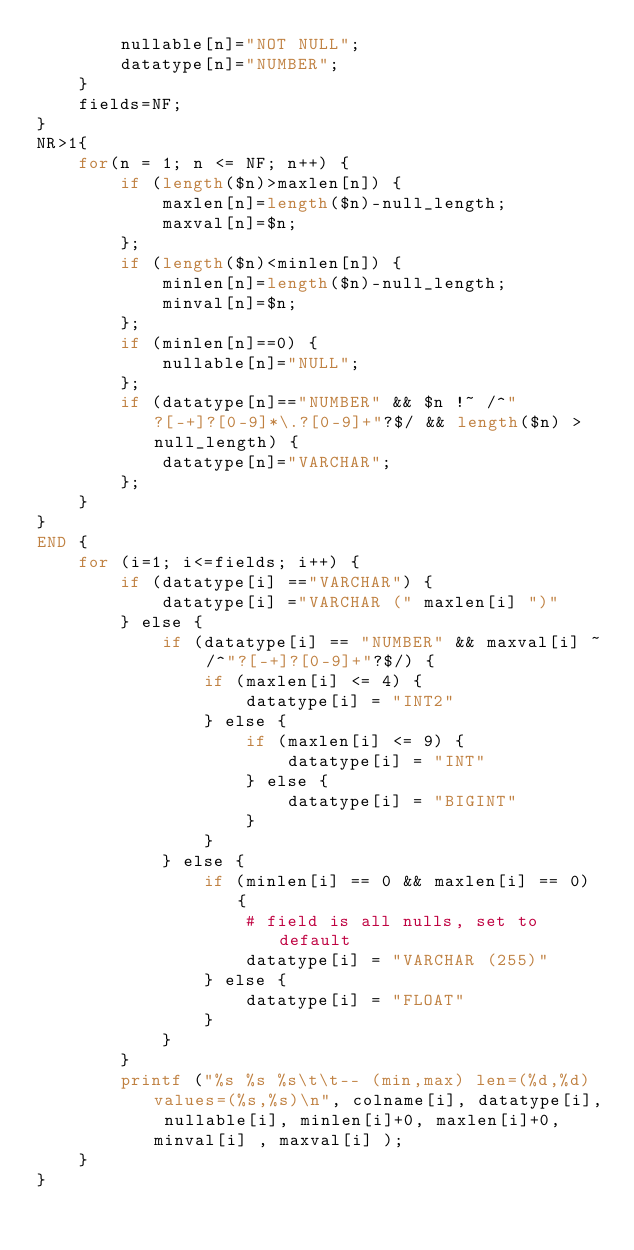<code> <loc_0><loc_0><loc_500><loc_500><_Awk_>        nullable[n]="NOT NULL";
        datatype[n]="NUMBER";
    }
    fields=NF;
}
NR>1{
    for(n = 1; n <= NF; n++) {
        if (length($n)>maxlen[n]) {
            maxlen[n]=length($n)-null_length;
            maxval[n]=$n;
        };
        if (length($n)<minlen[n]) {
            minlen[n]=length($n)-null_length;
            minval[n]=$n;
        };
        if (minlen[n]==0) {
            nullable[n]="NULL";
        };
        if (datatype[n]=="NUMBER" && $n !~ /^"?[-+]?[0-9]*\.?[0-9]+"?$/ && length($n) > null_length) {
            datatype[n]="VARCHAR";
        };
    }
}
END {
    for (i=1; i<=fields; i++) {
        if (datatype[i] =="VARCHAR") {
            datatype[i] ="VARCHAR (" maxlen[i] ")"
        } else {
            if (datatype[i] == "NUMBER" && maxval[i] ~ /^"?[-+]?[0-9]+"?$/) {
                if (maxlen[i] <= 4) {
                    datatype[i] = "INT2"
                } else {
                    if (maxlen[i] <= 9) {
                        datatype[i] = "INT"
                    } else {
                        datatype[i] = "BIGINT"
                    }
                }
            } else {
                if (minlen[i] == 0 && maxlen[i] == 0) {
                    # field is all nulls, set to default
                    datatype[i] = "VARCHAR (255)"
                } else {
                    datatype[i] = "FLOAT"
                }
            }
        }
        printf ("%s %s %s\t\t-- (min,max) len=(%d,%d) values=(%s,%s)\n", colname[i], datatype[i], nullable[i], minlen[i]+0, maxlen[i]+0, minval[i] , maxval[i] );
    }
}
</code> 